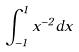Convert formula to latex. <formula><loc_0><loc_0><loc_500><loc_500>\int _ { - 1 } ^ { 1 } x ^ { - 2 } d x</formula> 